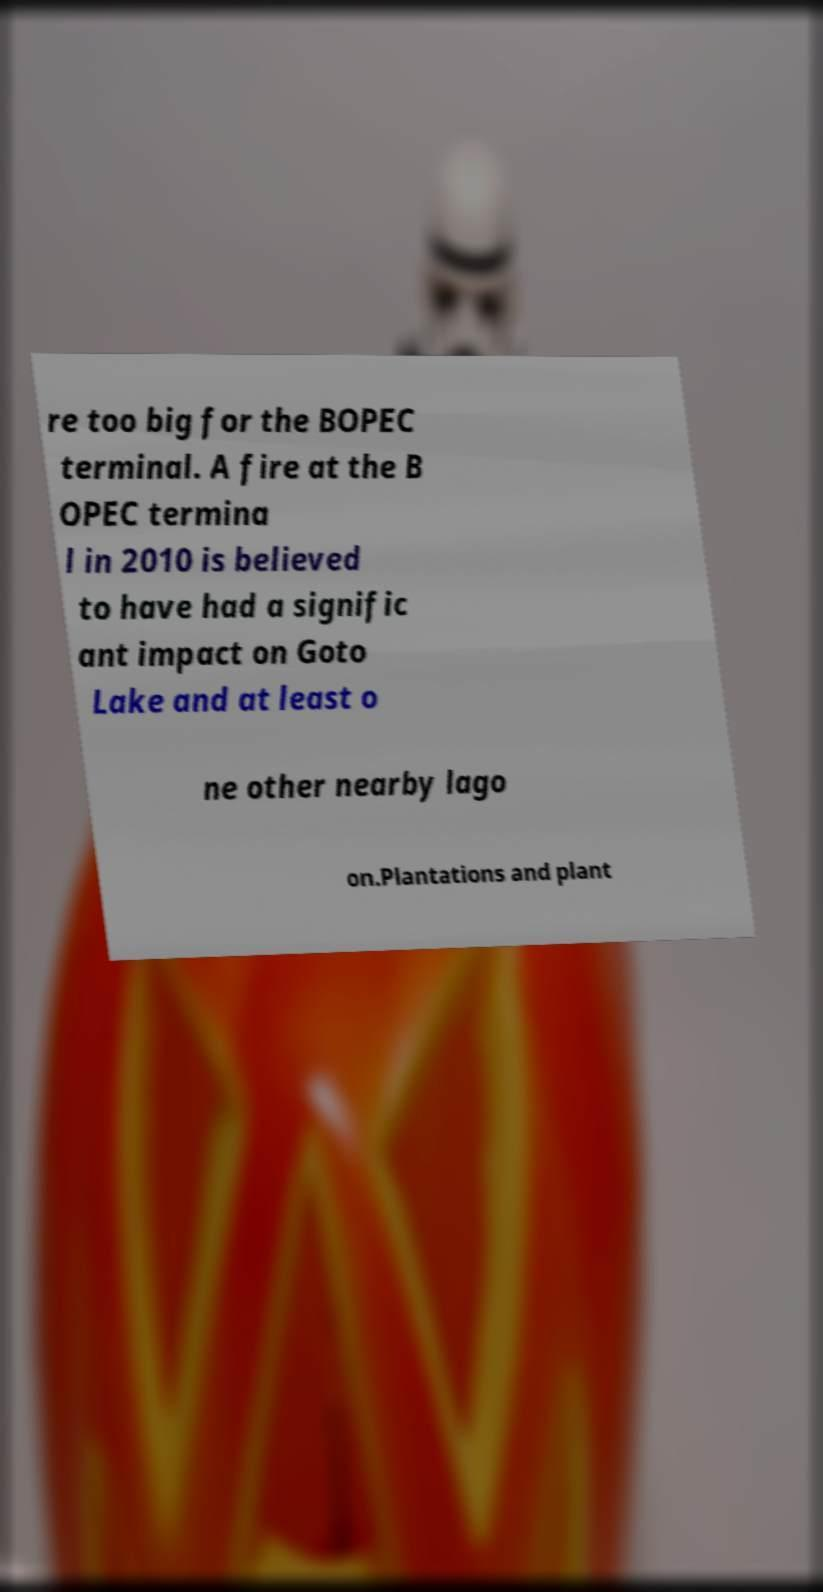Could you assist in decoding the text presented in this image and type it out clearly? re too big for the BOPEC terminal. A fire at the B OPEC termina l in 2010 is believed to have had a signific ant impact on Goto Lake and at least o ne other nearby lago on.Plantations and plant 